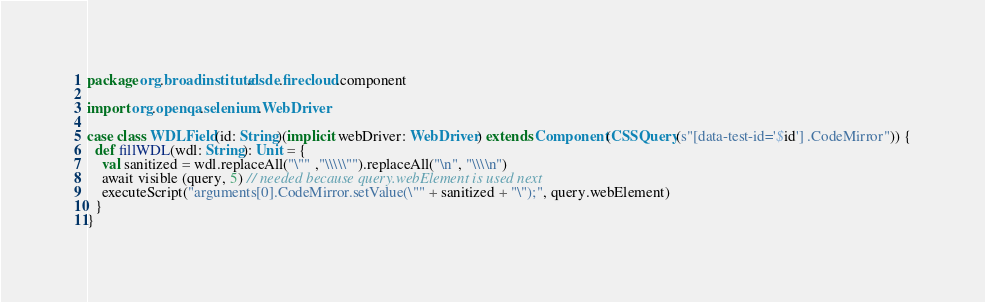<code> <loc_0><loc_0><loc_500><loc_500><_Scala_>package org.broadinstitute.dsde.firecloud.component

import org.openqa.selenium.WebDriver

case class WDLField(id: String)(implicit webDriver: WebDriver) extends Component(CSSQuery(s"[data-test-id='$id'] .CodeMirror")) {
  def fillWDL(wdl: String): Unit = {
    val sanitized = wdl.replaceAll("\"" ,"\\\\\"").replaceAll("\n", "\\\\n")
    await visible (query, 5) // needed because query.webElement is used next
    executeScript("arguments[0].CodeMirror.setValue(\"" + sanitized + "\");", query.webElement)
  }
}
</code> 